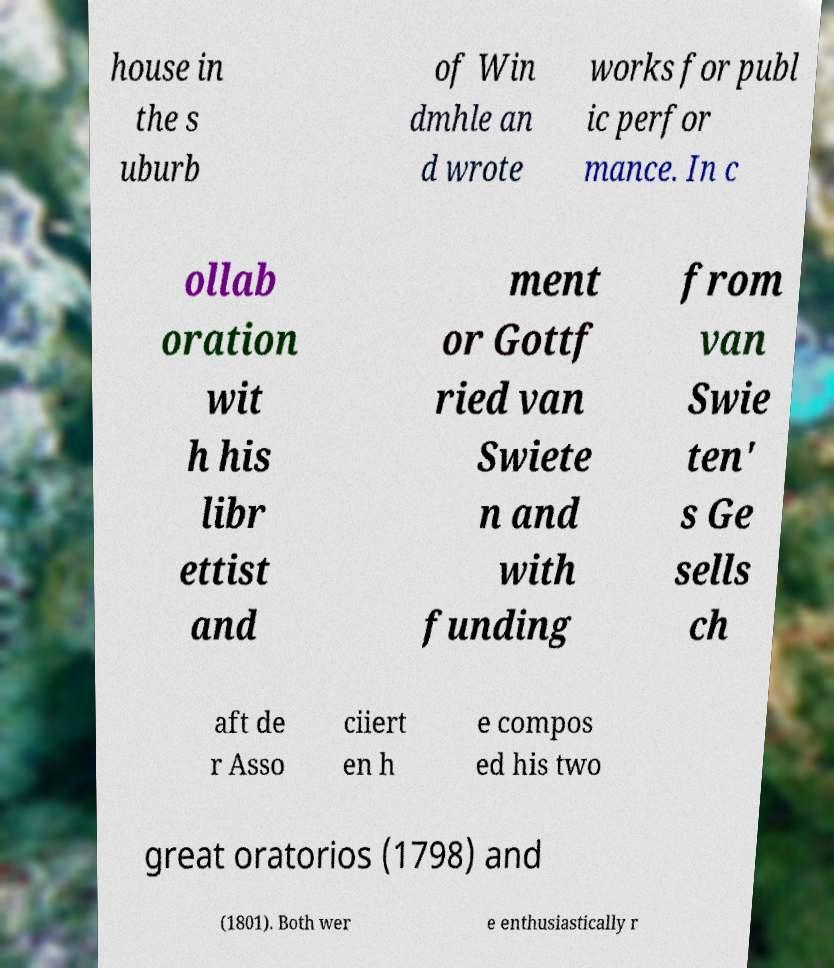Please identify and transcribe the text found in this image. house in the s uburb of Win dmhle an d wrote works for publ ic perfor mance. In c ollab oration wit h his libr ettist and ment or Gottf ried van Swiete n and with funding from van Swie ten' s Ge sells ch aft de r Asso ciiert en h e compos ed his two great oratorios (1798) and (1801). Both wer e enthusiastically r 